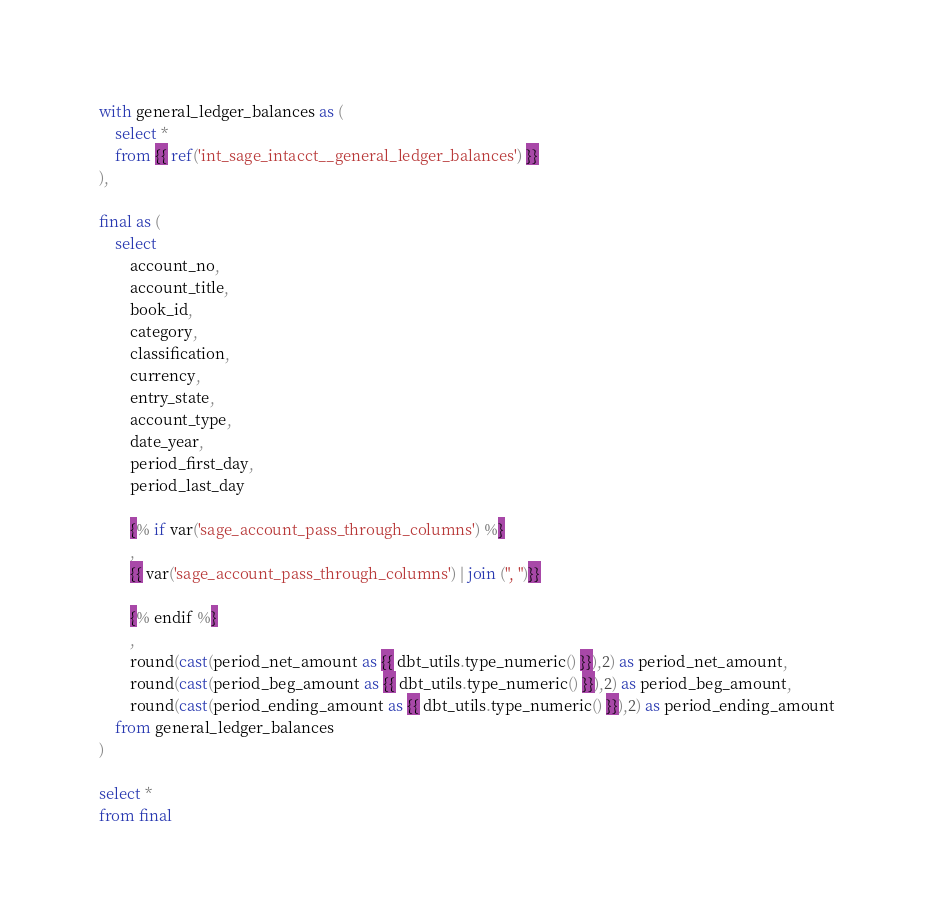Convert code to text. <code><loc_0><loc_0><loc_500><loc_500><_SQL_>
with general_ledger_balances as (
    select *
    from {{ ref('int_sage_intacct__general_ledger_balances') }}
), 

final as (
    select 
        account_no,
        account_title,
        book_id,
        category,
        classification,
        currency,
        entry_state,
        account_type,
        date_year, 
        period_first_day,
        period_last_day

        {% if var('sage_account_pass_through_columns') %} 
        ,
        {{ var('sage_account_pass_through_columns') | join (", ")}}

        {% endif %}
        ,
        round(cast(period_net_amount as {{ dbt_utils.type_numeric() }}),2) as period_net_amount,
        round(cast(period_beg_amount as {{ dbt_utils.type_numeric() }}),2) as period_beg_amount,
        round(cast(period_ending_amount as {{ dbt_utils.type_numeric() }}),2) as period_ending_amount
    from general_ledger_balances
)

select * 
from final 
</code> 